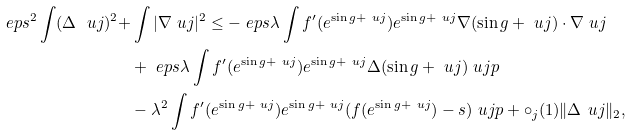<formula> <loc_0><loc_0><loc_500><loc_500>\ e p s ^ { 2 } \int ( \Delta \ u j ) ^ { 2 } + & \int | \nabla \ u j | ^ { 2 } \leq - \ e p s \lambda \int f ^ { \prime } ( e ^ { \sin g + \ u j } ) e ^ { \sin g + \ u j } \nabla ( \sin g + \ u j ) \cdot \nabla \ u j \\ & + \ e p s \lambda \int f ^ { \prime } ( e ^ { \sin g + \ u j } ) e ^ { \sin g + \ u j } \Delta ( \sin g + \ u j ) \ u j p \\ & - \lambda ^ { 2 } \int f ^ { \prime } ( e ^ { \sin g + \ u j } ) e ^ { \sin g + \ u j } ( f ( e ^ { \sin g + \ u j } ) - s ) \ u j p + \circ _ { j } ( 1 ) \| \Delta \ u j \| _ { 2 } ,</formula> 